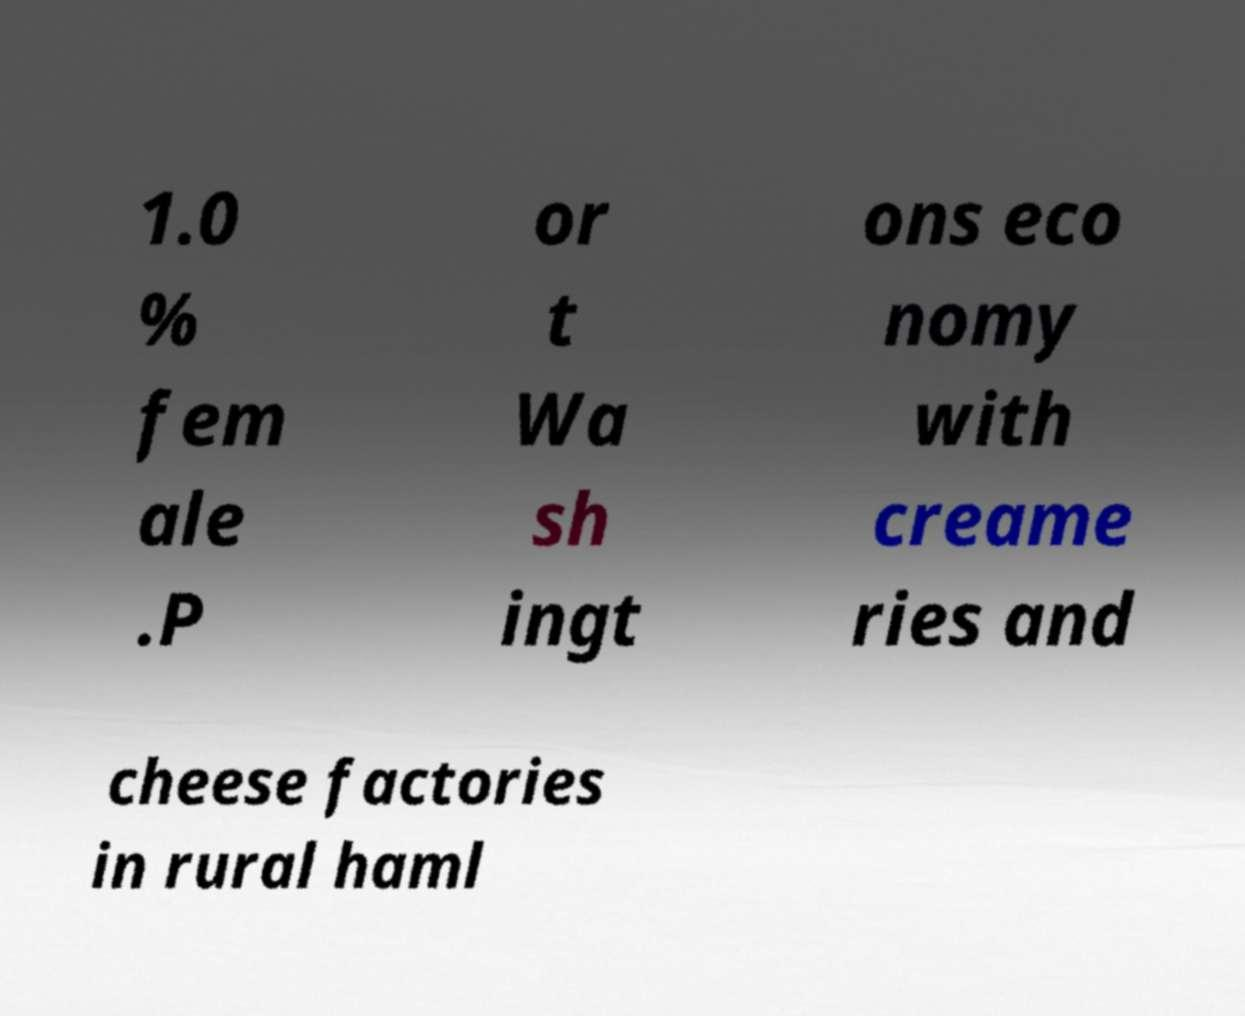There's text embedded in this image that I need extracted. Can you transcribe it verbatim? 1.0 % fem ale .P or t Wa sh ingt ons eco nomy with creame ries and cheese factories in rural haml 